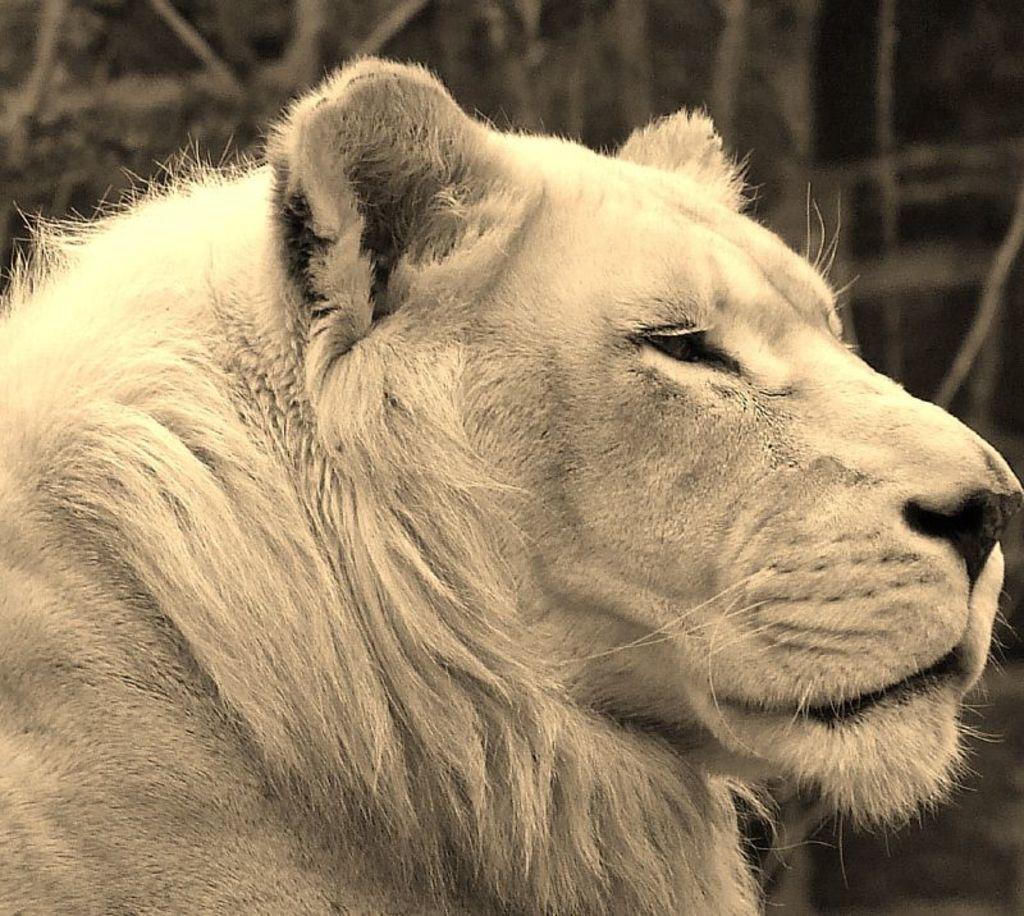Can you describe this image briefly? This is a black and white image and here we can see a lion. 